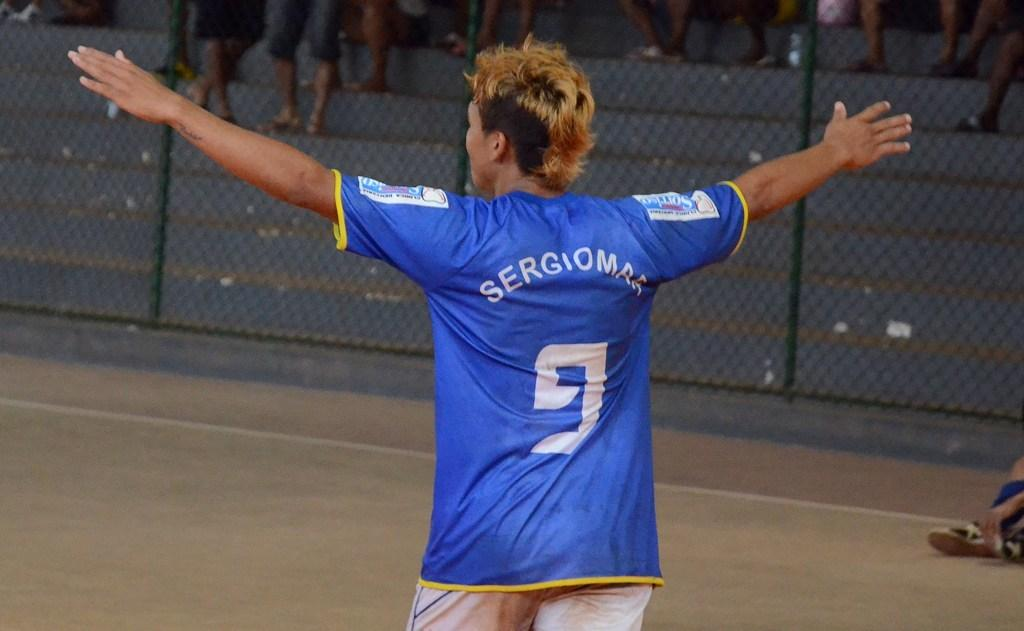Provide a one-sentence caption for the provided image. A person on a field wearing a light blue soccer jersey with number 9 on the back. 